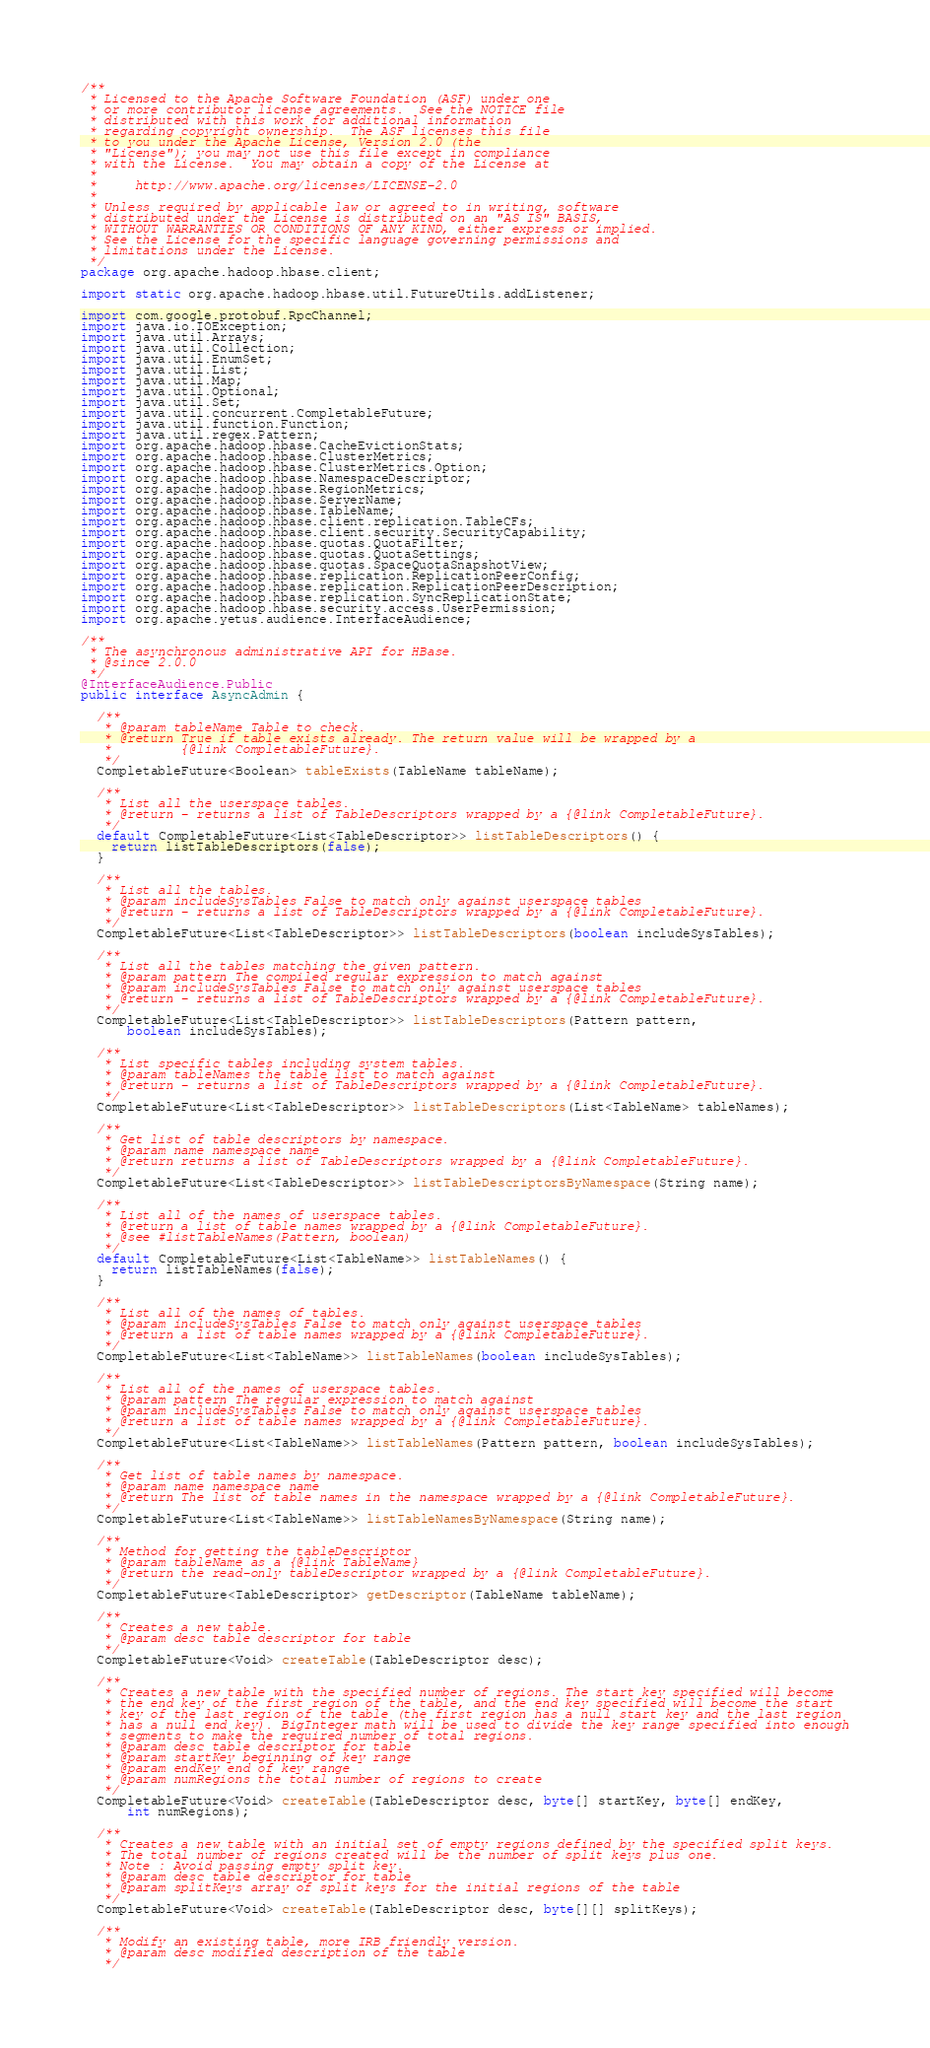<code> <loc_0><loc_0><loc_500><loc_500><_Java_>/**
 * Licensed to the Apache Software Foundation (ASF) under one
 * or more contributor license agreements.  See the NOTICE file
 * distributed with this work for additional information
 * regarding copyright ownership.  The ASF licenses this file
 * to you under the Apache License, Version 2.0 (the
 * "License"); you may not use this file except in compliance
 * with the License.  You may obtain a copy of the License at
 *
 *     http://www.apache.org/licenses/LICENSE-2.0
 *
 * Unless required by applicable law or agreed to in writing, software
 * distributed under the License is distributed on an "AS IS" BASIS,
 * WITHOUT WARRANTIES OR CONDITIONS OF ANY KIND, either express or implied.
 * See the License for the specific language governing permissions and
 * limitations under the License.
 */
package org.apache.hadoop.hbase.client;

import static org.apache.hadoop.hbase.util.FutureUtils.addListener;

import com.google.protobuf.RpcChannel;
import java.io.IOException;
import java.util.Arrays;
import java.util.Collection;
import java.util.EnumSet;
import java.util.List;
import java.util.Map;
import java.util.Optional;
import java.util.Set;
import java.util.concurrent.CompletableFuture;
import java.util.function.Function;
import java.util.regex.Pattern;
import org.apache.hadoop.hbase.CacheEvictionStats;
import org.apache.hadoop.hbase.ClusterMetrics;
import org.apache.hadoop.hbase.ClusterMetrics.Option;
import org.apache.hadoop.hbase.NamespaceDescriptor;
import org.apache.hadoop.hbase.RegionMetrics;
import org.apache.hadoop.hbase.ServerName;
import org.apache.hadoop.hbase.TableName;
import org.apache.hadoop.hbase.client.replication.TableCFs;
import org.apache.hadoop.hbase.client.security.SecurityCapability;
import org.apache.hadoop.hbase.quotas.QuotaFilter;
import org.apache.hadoop.hbase.quotas.QuotaSettings;
import org.apache.hadoop.hbase.quotas.SpaceQuotaSnapshotView;
import org.apache.hadoop.hbase.replication.ReplicationPeerConfig;
import org.apache.hadoop.hbase.replication.ReplicationPeerDescription;
import org.apache.hadoop.hbase.replication.SyncReplicationState;
import org.apache.hadoop.hbase.security.access.UserPermission;
import org.apache.yetus.audience.InterfaceAudience;

/**
 * The asynchronous administrative API for HBase.
 * @since 2.0.0
 */
@InterfaceAudience.Public
public interface AsyncAdmin {

  /**
   * @param tableName Table to check.
   * @return True if table exists already. The return value will be wrapped by a
   *         {@link CompletableFuture}.
   */
  CompletableFuture<Boolean> tableExists(TableName tableName);

  /**
   * List all the userspace tables.
   * @return - returns a list of TableDescriptors wrapped by a {@link CompletableFuture}.
   */
  default CompletableFuture<List<TableDescriptor>> listTableDescriptors() {
    return listTableDescriptors(false);
  }

  /**
   * List all the tables.
   * @param includeSysTables False to match only against userspace tables
   * @return - returns a list of TableDescriptors wrapped by a {@link CompletableFuture}.
   */
  CompletableFuture<List<TableDescriptor>> listTableDescriptors(boolean includeSysTables);

  /**
   * List all the tables matching the given pattern.
   * @param pattern The compiled regular expression to match against
   * @param includeSysTables False to match only against userspace tables
   * @return - returns a list of TableDescriptors wrapped by a {@link CompletableFuture}.
   */
  CompletableFuture<List<TableDescriptor>> listTableDescriptors(Pattern pattern,
      boolean includeSysTables);

  /**
   * List specific tables including system tables.
   * @param tableNames the table list to match against
   * @return - returns a list of TableDescriptors wrapped by a {@link CompletableFuture}.
   */
  CompletableFuture<List<TableDescriptor>> listTableDescriptors(List<TableName> tableNames);

  /**
   * Get list of table descriptors by namespace.
   * @param name namespace name
   * @return returns a list of TableDescriptors wrapped by a {@link CompletableFuture}.
   */
  CompletableFuture<List<TableDescriptor>> listTableDescriptorsByNamespace(String name);

  /**
   * List all of the names of userspace tables.
   * @return a list of table names wrapped by a {@link CompletableFuture}.
   * @see #listTableNames(Pattern, boolean)
   */
  default CompletableFuture<List<TableName>> listTableNames() {
    return listTableNames(false);
  }

  /**
   * List all of the names of tables.
   * @param includeSysTables False to match only against userspace tables
   * @return a list of table names wrapped by a {@link CompletableFuture}.
   */
  CompletableFuture<List<TableName>> listTableNames(boolean includeSysTables);

  /**
   * List all of the names of userspace tables.
   * @param pattern The regular expression to match against
   * @param includeSysTables False to match only against userspace tables
   * @return a list of table names wrapped by a {@link CompletableFuture}.
   */
  CompletableFuture<List<TableName>> listTableNames(Pattern pattern, boolean includeSysTables);

  /**
   * Get list of table names by namespace.
   * @param name namespace name
   * @return The list of table names in the namespace wrapped by a {@link CompletableFuture}.
   */
  CompletableFuture<List<TableName>> listTableNamesByNamespace(String name);

  /**
   * Method for getting the tableDescriptor
   * @param tableName as a {@link TableName}
   * @return the read-only tableDescriptor wrapped by a {@link CompletableFuture}.
   */
  CompletableFuture<TableDescriptor> getDescriptor(TableName tableName);

  /**
   * Creates a new table.
   * @param desc table descriptor for table
   */
  CompletableFuture<Void> createTable(TableDescriptor desc);

  /**
   * Creates a new table with the specified number of regions. The start key specified will become
   * the end key of the first region of the table, and the end key specified will become the start
   * key of the last region of the table (the first region has a null start key and the last region
   * has a null end key). BigInteger math will be used to divide the key range specified into enough
   * segments to make the required number of total regions.
   * @param desc table descriptor for table
   * @param startKey beginning of key range
   * @param endKey end of key range
   * @param numRegions the total number of regions to create
   */
  CompletableFuture<Void> createTable(TableDescriptor desc, byte[] startKey, byte[] endKey,
      int numRegions);

  /**
   * Creates a new table with an initial set of empty regions defined by the specified split keys.
   * The total number of regions created will be the number of split keys plus one.
   * Note : Avoid passing empty split key.
   * @param desc table descriptor for table
   * @param splitKeys array of split keys for the initial regions of the table
   */
  CompletableFuture<Void> createTable(TableDescriptor desc, byte[][] splitKeys);

  /**
   * Modify an existing table, more IRB friendly version.
   * @param desc modified description of the table
   */</code> 